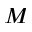Convert formula to latex. <formula><loc_0><loc_0><loc_500><loc_500>M</formula> 